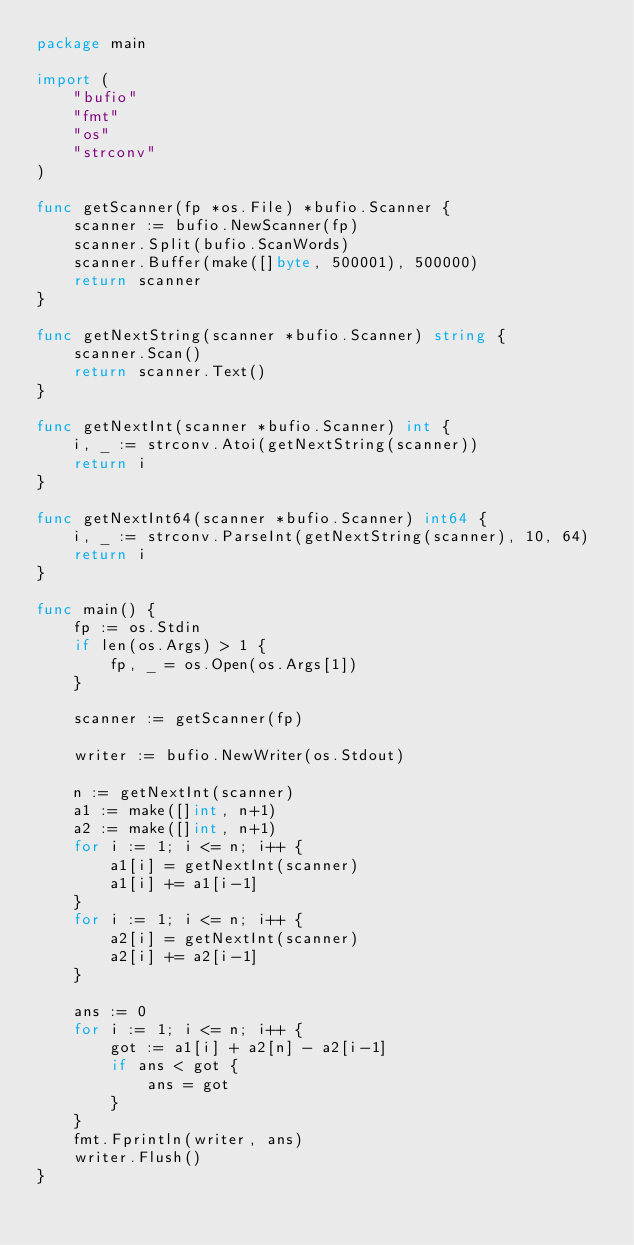<code> <loc_0><loc_0><loc_500><loc_500><_Go_>package main

import (
	"bufio"
	"fmt"
	"os"
	"strconv"
)

func getScanner(fp *os.File) *bufio.Scanner {
	scanner := bufio.NewScanner(fp)
	scanner.Split(bufio.ScanWords)
	scanner.Buffer(make([]byte, 500001), 500000)
	return scanner
}

func getNextString(scanner *bufio.Scanner) string {
	scanner.Scan()
	return scanner.Text()
}

func getNextInt(scanner *bufio.Scanner) int {
	i, _ := strconv.Atoi(getNextString(scanner))
	return i
}

func getNextInt64(scanner *bufio.Scanner) int64 {
	i, _ := strconv.ParseInt(getNextString(scanner), 10, 64)
	return i
}

func main() {
	fp := os.Stdin
	if len(os.Args) > 1 {
		fp, _ = os.Open(os.Args[1])
	}

	scanner := getScanner(fp)

	writer := bufio.NewWriter(os.Stdout)

	n := getNextInt(scanner)
	a1 := make([]int, n+1)
	a2 := make([]int, n+1)
	for i := 1; i <= n; i++ {
		a1[i] = getNextInt(scanner)
		a1[i] += a1[i-1]
	}
	for i := 1; i <= n; i++ {
		a2[i] = getNextInt(scanner)
		a2[i] += a2[i-1]
	}

	ans := 0
	for i := 1; i <= n; i++ {
		got := a1[i] + a2[n] - a2[i-1]
		if ans < got {
			ans = got
		}
	}
	fmt.Fprintln(writer, ans)
	writer.Flush()
}
</code> 